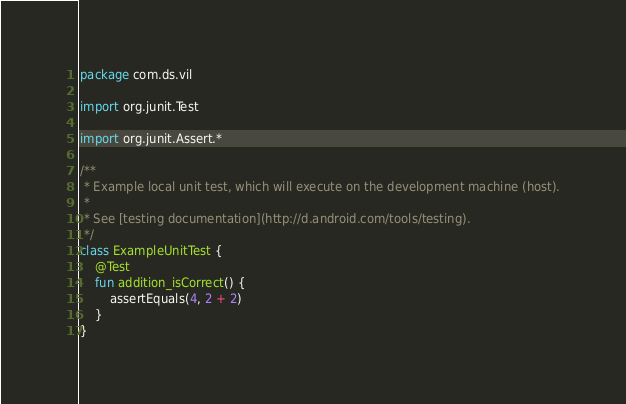<code> <loc_0><loc_0><loc_500><loc_500><_Kotlin_>package com.ds.vil

import org.junit.Test

import org.junit.Assert.*

/**
 * Example local unit test, which will execute on the development machine (host).
 *
 * See [testing documentation](http://d.android.com/tools/testing).
 */
class ExampleUnitTest {
    @Test
    fun addition_isCorrect() {
        assertEquals(4, 2 + 2)
    }
}
</code> 